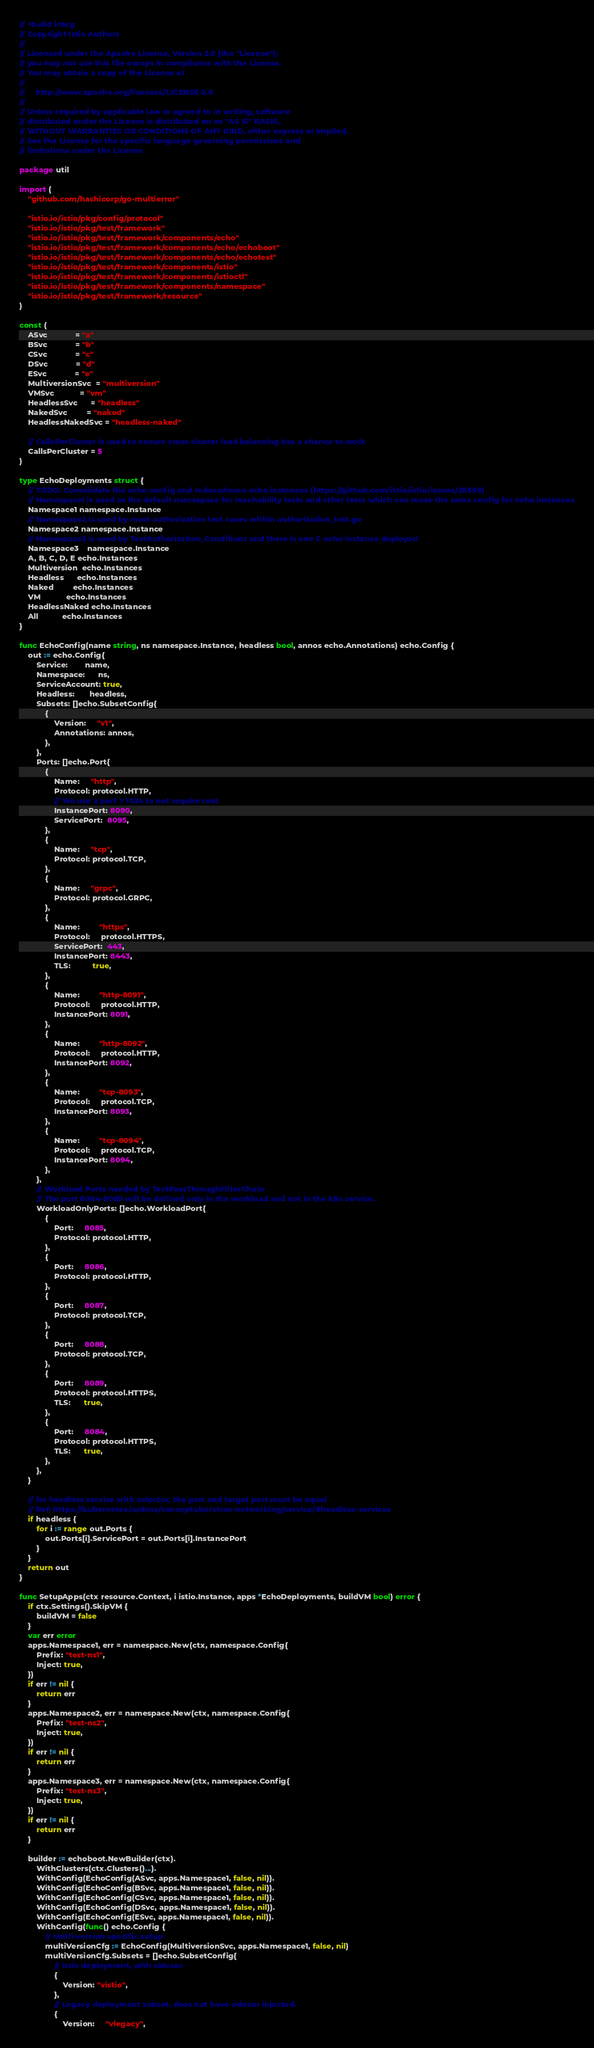Convert code to text. <code><loc_0><loc_0><loc_500><loc_500><_Go_>// +build integ
// Copyright Istio Authors
//
// Licensed under the Apache License, Version 2.0 (the "License");
// you may not use this file except in compliance with the License.
// You may obtain a copy of the License at
//
//     http://www.apache.org/licenses/LICENSE-2.0
//
// Unless required by applicable law or agreed to in writing, software
// distributed under the License is distributed on an "AS IS" BASIS,
// WITHOUT WARRANTIES OR CONDITIONS OF ANY KIND, either express or implied.
// See the License for the specific language governing permissions and
// limitations under the License.

package util

import (
	"github.com/hashicorp/go-multierror"

	"istio.io/istio/pkg/config/protocol"
	"istio.io/istio/pkg/test/framework"
	"istio.io/istio/pkg/test/framework/components/echo"
	"istio.io/istio/pkg/test/framework/components/echo/echoboot"
	"istio.io/istio/pkg/test/framework/components/echo/echotest"
	"istio.io/istio/pkg/test/framework/components/istio"
	"istio.io/istio/pkg/test/framework/components/istioctl"
	"istio.io/istio/pkg/test/framework/components/namespace"
	"istio.io/istio/pkg/test/framework/resource"
)

const (
	ASvc             = "a"
	BSvc             = "b"
	CSvc             = "c"
	DSvc             = "d"
	ESvc             = "e"
	MultiversionSvc  = "multiversion"
	VMSvc            = "vm"
	HeadlessSvc      = "headless"
	NakedSvc         = "naked"
	HeadlessNakedSvc = "headless-naked"

	// CallsPerCluster is used to ensure cross-cluster load balancing has a chance to work
	CallsPerCluster = 5
)

type EchoDeployments struct {
	// TODO: Consolidate the echo config and reduce/reuse echo instances (https://github.com/istio/istio/issues/28599)
	// Namespace1 is used as the default namespace for reachability tests and other tests which can reuse the same config for echo instances
	Namespace1 namespace.Instance
	// Namespace2 is used by most authorization test cases within authorization_test.go
	Namespace2 namespace.Instance
	// Namespace3 is used by TestAuthorization_Conditions and there is one C echo instance deployed
	Namespace3    namespace.Instance
	A, B, C, D, E echo.Instances
	Multiversion  echo.Instances
	Headless      echo.Instances
	Naked         echo.Instances
	VM            echo.Instances
	HeadlessNaked echo.Instances
	All           echo.Instances
}

func EchoConfig(name string, ns namespace.Instance, headless bool, annos echo.Annotations) echo.Config {
	out := echo.Config{
		Service:        name,
		Namespace:      ns,
		ServiceAccount: true,
		Headless:       headless,
		Subsets: []echo.SubsetConfig{
			{
				Version:     "v1",
				Annotations: annos,
			},
		},
		Ports: []echo.Port{
			{
				Name:     "http",
				Protocol: protocol.HTTP,
				// We use a port > 1024 to not require root
				InstancePort: 8090,
				ServicePort:  8095,
			},
			{
				Name:     "tcp",
				Protocol: protocol.TCP,
			},
			{
				Name:     "grpc",
				Protocol: protocol.GRPC,
			},
			{
				Name:         "https",
				Protocol:     protocol.HTTPS,
				ServicePort:  443,
				InstancePort: 8443,
				TLS:          true,
			},
			{
				Name:         "http-8091",
				Protocol:     protocol.HTTP,
				InstancePort: 8091,
			},
			{
				Name:         "http-8092",
				Protocol:     protocol.HTTP,
				InstancePort: 8092,
			},
			{
				Name:         "tcp-8093",
				Protocol:     protocol.TCP,
				InstancePort: 8093,
			},
			{
				Name:         "tcp-8094",
				Protocol:     protocol.TCP,
				InstancePort: 8094,
			},
		},
		// Workload Ports needed by TestPassThroughFilterChain
		// The port 8084-8089 will be defined only in the workload and not in the k8s service.
		WorkloadOnlyPorts: []echo.WorkloadPort{
			{
				Port:     8085,
				Protocol: protocol.HTTP,
			},
			{
				Port:     8086,
				Protocol: protocol.HTTP,
			},
			{
				Port:     8087,
				Protocol: protocol.TCP,
			},
			{
				Port:     8088,
				Protocol: protocol.TCP,
			},
			{
				Port:     8089,
				Protocol: protocol.HTTPS,
				TLS:      true,
			},
			{
				Port:     8084,
				Protocol: protocol.HTTPS,
				TLS:      true,
			},
		},
	}

	// for headless service with selector, the port and target port must be equal
	// Ref: https://kubernetes.io/docs/concepts/services-networking/service/#headless-services
	if headless {
		for i := range out.Ports {
			out.Ports[i].ServicePort = out.Ports[i].InstancePort
		}
	}
	return out
}

func SetupApps(ctx resource.Context, i istio.Instance, apps *EchoDeployments, buildVM bool) error {
	if ctx.Settings().SkipVM {
		buildVM = false
	}
	var err error
	apps.Namespace1, err = namespace.New(ctx, namespace.Config{
		Prefix: "test-ns1",
		Inject: true,
	})
	if err != nil {
		return err
	}
	apps.Namespace2, err = namespace.New(ctx, namespace.Config{
		Prefix: "test-ns2",
		Inject: true,
	})
	if err != nil {
		return err
	}
	apps.Namespace3, err = namespace.New(ctx, namespace.Config{
		Prefix: "test-ns3",
		Inject: true,
	})
	if err != nil {
		return err
	}

	builder := echoboot.NewBuilder(ctx).
		WithClusters(ctx.Clusters()...).
		WithConfig(EchoConfig(ASvc, apps.Namespace1, false, nil)).
		WithConfig(EchoConfig(BSvc, apps.Namespace1, false, nil)).
		WithConfig(EchoConfig(CSvc, apps.Namespace1, false, nil)).
		WithConfig(EchoConfig(DSvc, apps.Namespace1, false, nil)).
		WithConfig(EchoConfig(ESvc, apps.Namespace1, false, nil)).
		WithConfig(func() echo.Config {
			// Multi-version specific setup
			multiVersionCfg := EchoConfig(MultiversionSvc, apps.Namespace1, false, nil)
			multiVersionCfg.Subsets = []echo.SubsetConfig{
				// Istio deployment, with sidecar.
				{
					Version: "vistio",
				},
				// Legacy deployment subset, does not have sidecar injected.
				{
					Version:     "vlegacy",</code> 